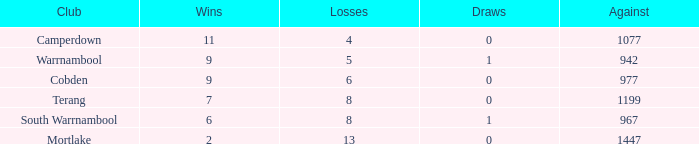What is the draw in a situation where there were over 8 losses and fewer than 2 wins? None. 